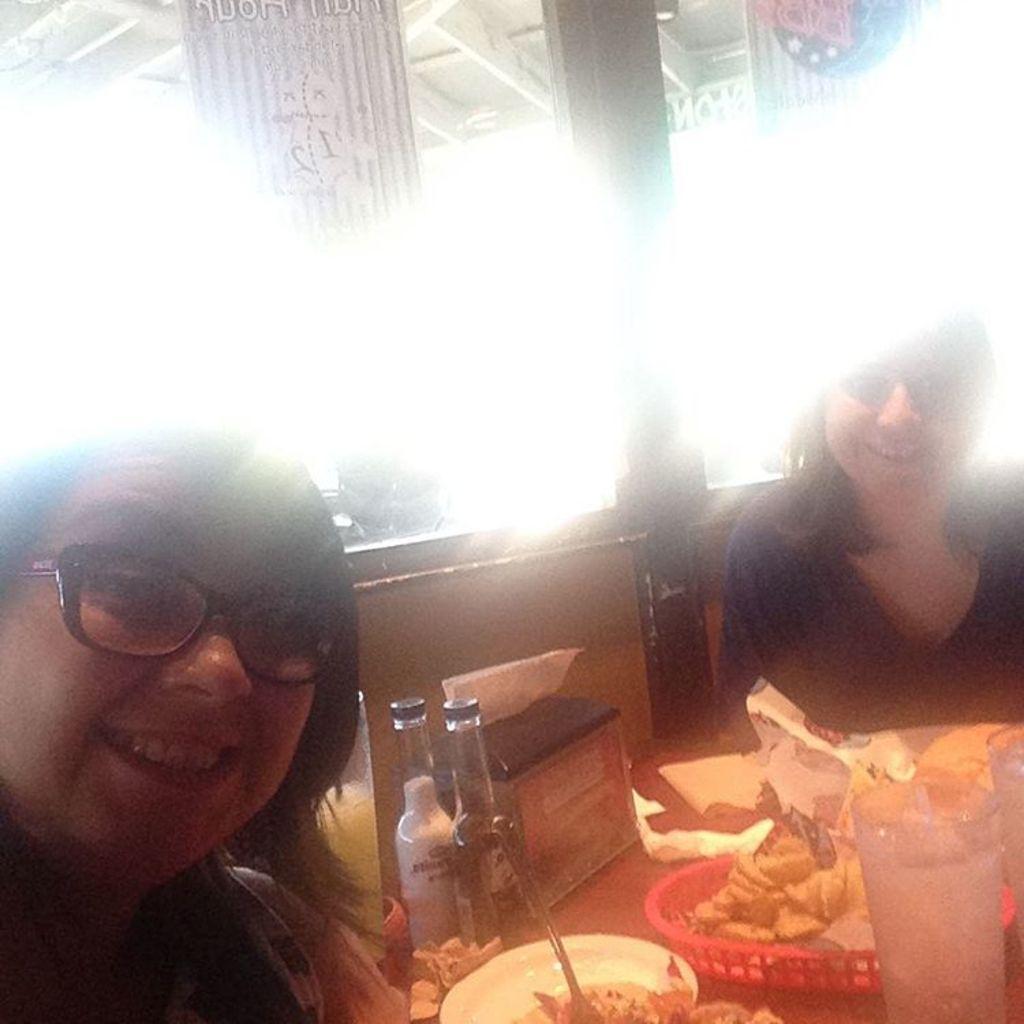Could you give a brief overview of what you see in this image? In this image there are two women smiling and are sitting in front of the dining table and on the table there are two glass bottles, a bowl of food with a spoon, tissue papers, a basket with food, two glasses and a tissue box. In the background there is a pillar, and also hoarding hanged from ceiling and the image is full of lightening. 